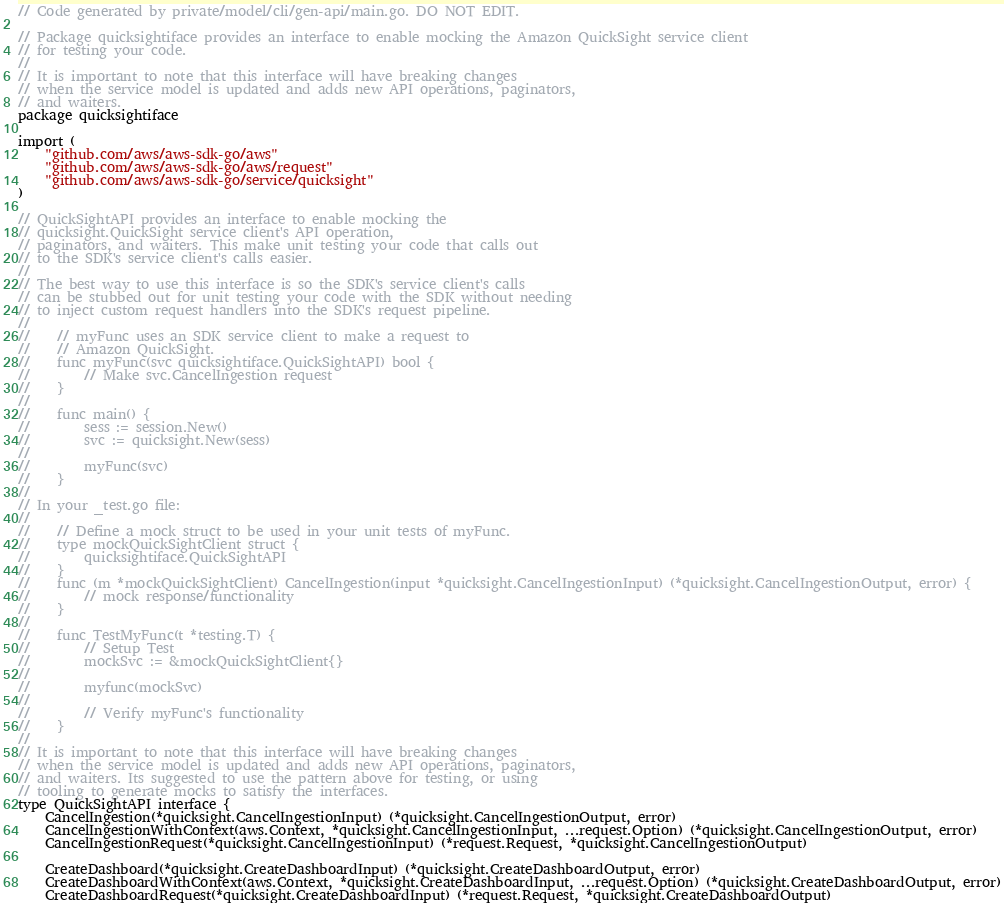Convert code to text. <code><loc_0><loc_0><loc_500><loc_500><_Go_>// Code generated by private/model/cli/gen-api/main.go. DO NOT EDIT.

// Package quicksightiface provides an interface to enable mocking the Amazon QuickSight service client
// for testing your code.
//
// It is important to note that this interface will have breaking changes
// when the service model is updated and adds new API operations, paginators,
// and waiters.
package quicksightiface

import (
	"github.com/aws/aws-sdk-go/aws"
	"github.com/aws/aws-sdk-go/aws/request"
	"github.com/aws/aws-sdk-go/service/quicksight"
)

// QuickSightAPI provides an interface to enable mocking the
// quicksight.QuickSight service client's API operation,
// paginators, and waiters. This make unit testing your code that calls out
// to the SDK's service client's calls easier.
//
// The best way to use this interface is so the SDK's service client's calls
// can be stubbed out for unit testing your code with the SDK without needing
// to inject custom request handlers into the SDK's request pipeline.
//
//    // myFunc uses an SDK service client to make a request to
//    // Amazon QuickSight.
//    func myFunc(svc quicksightiface.QuickSightAPI) bool {
//        // Make svc.CancelIngestion request
//    }
//
//    func main() {
//        sess := session.New()
//        svc := quicksight.New(sess)
//
//        myFunc(svc)
//    }
//
// In your _test.go file:
//
//    // Define a mock struct to be used in your unit tests of myFunc.
//    type mockQuickSightClient struct {
//        quicksightiface.QuickSightAPI
//    }
//    func (m *mockQuickSightClient) CancelIngestion(input *quicksight.CancelIngestionInput) (*quicksight.CancelIngestionOutput, error) {
//        // mock response/functionality
//    }
//
//    func TestMyFunc(t *testing.T) {
//        // Setup Test
//        mockSvc := &mockQuickSightClient{}
//
//        myfunc(mockSvc)
//
//        // Verify myFunc's functionality
//    }
//
// It is important to note that this interface will have breaking changes
// when the service model is updated and adds new API operations, paginators,
// and waiters. Its suggested to use the pattern above for testing, or using
// tooling to generate mocks to satisfy the interfaces.
type QuickSightAPI interface {
	CancelIngestion(*quicksight.CancelIngestionInput) (*quicksight.CancelIngestionOutput, error)
	CancelIngestionWithContext(aws.Context, *quicksight.CancelIngestionInput, ...request.Option) (*quicksight.CancelIngestionOutput, error)
	CancelIngestionRequest(*quicksight.CancelIngestionInput) (*request.Request, *quicksight.CancelIngestionOutput)

	CreateDashboard(*quicksight.CreateDashboardInput) (*quicksight.CreateDashboardOutput, error)
	CreateDashboardWithContext(aws.Context, *quicksight.CreateDashboardInput, ...request.Option) (*quicksight.CreateDashboardOutput, error)
	CreateDashboardRequest(*quicksight.CreateDashboardInput) (*request.Request, *quicksight.CreateDashboardOutput)
</code> 